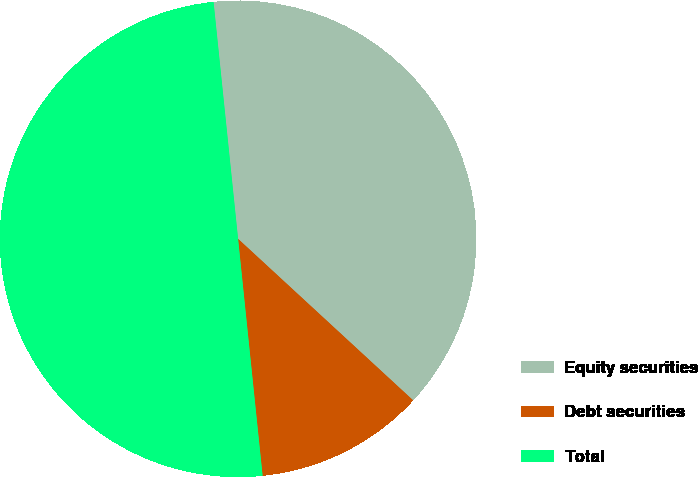<chart> <loc_0><loc_0><loc_500><loc_500><pie_chart><fcel>Equity securities<fcel>Debt securities<fcel>Total<nl><fcel>38.5%<fcel>11.5%<fcel>50.0%<nl></chart> 